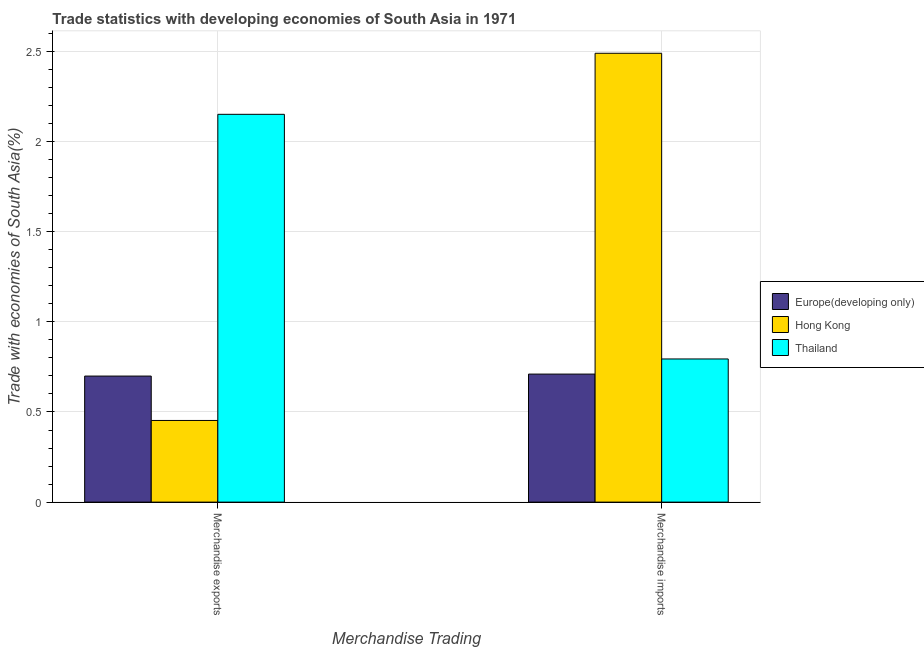How many different coloured bars are there?
Ensure brevity in your answer.  3. Are the number of bars on each tick of the X-axis equal?
Offer a very short reply. Yes. What is the merchandise exports in Thailand?
Give a very brief answer. 2.15. Across all countries, what is the maximum merchandise imports?
Your response must be concise. 2.49. Across all countries, what is the minimum merchandise imports?
Offer a terse response. 0.71. In which country was the merchandise imports maximum?
Ensure brevity in your answer.  Hong Kong. In which country was the merchandise exports minimum?
Ensure brevity in your answer.  Hong Kong. What is the total merchandise exports in the graph?
Keep it short and to the point. 3.3. What is the difference between the merchandise exports in Hong Kong and that in Europe(developing only)?
Provide a short and direct response. -0.25. What is the difference between the merchandise exports in Europe(developing only) and the merchandise imports in Hong Kong?
Provide a short and direct response. -1.79. What is the average merchandise imports per country?
Your response must be concise. 1.33. What is the difference between the merchandise imports and merchandise exports in Hong Kong?
Keep it short and to the point. 2.04. In how many countries, is the merchandise imports greater than 0.2 %?
Your answer should be very brief. 3. What is the ratio of the merchandise exports in Thailand to that in Europe(developing only)?
Your answer should be compact. 3.08. In how many countries, is the merchandise imports greater than the average merchandise imports taken over all countries?
Ensure brevity in your answer.  1. What does the 3rd bar from the left in Merchandise exports represents?
Your answer should be very brief. Thailand. What does the 3rd bar from the right in Merchandise exports represents?
Ensure brevity in your answer.  Europe(developing only). How many bars are there?
Your answer should be very brief. 6. Are all the bars in the graph horizontal?
Keep it short and to the point. No. What is the difference between two consecutive major ticks on the Y-axis?
Your response must be concise. 0.5. Does the graph contain grids?
Offer a very short reply. Yes. Where does the legend appear in the graph?
Keep it short and to the point. Center right. How are the legend labels stacked?
Your answer should be compact. Vertical. What is the title of the graph?
Give a very brief answer. Trade statistics with developing economies of South Asia in 1971. What is the label or title of the X-axis?
Your response must be concise. Merchandise Trading. What is the label or title of the Y-axis?
Offer a terse response. Trade with economies of South Asia(%). What is the Trade with economies of South Asia(%) in Europe(developing only) in Merchandise exports?
Offer a terse response. 0.7. What is the Trade with economies of South Asia(%) of Hong Kong in Merchandise exports?
Your response must be concise. 0.45. What is the Trade with economies of South Asia(%) of Thailand in Merchandise exports?
Keep it short and to the point. 2.15. What is the Trade with economies of South Asia(%) of Europe(developing only) in Merchandise imports?
Provide a short and direct response. 0.71. What is the Trade with economies of South Asia(%) in Hong Kong in Merchandise imports?
Your response must be concise. 2.49. What is the Trade with economies of South Asia(%) in Thailand in Merchandise imports?
Offer a very short reply. 0.79. Across all Merchandise Trading, what is the maximum Trade with economies of South Asia(%) in Europe(developing only)?
Make the answer very short. 0.71. Across all Merchandise Trading, what is the maximum Trade with economies of South Asia(%) of Hong Kong?
Give a very brief answer. 2.49. Across all Merchandise Trading, what is the maximum Trade with economies of South Asia(%) of Thailand?
Give a very brief answer. 2.15. Across all Merchandise Trading, what is the minimum Trade with economies of South Asia(%) of Europe(developing only)?
Your response must be concise. 0.7. Across all Merchandise Trading, what is the minimum Trade with economies of South Asia(%) in Hong Kong?
Keep it short and to the point. 0.45. Across all Merchandise Trading, what is the minimum Trade with economies of South Asia(%) in Thailand?
Offer a terse response. 0.79. What is the total Trade with economies of South Asia(%) of Europe(developing only) in the graph?
Your answer should be very brief. 1.41. What is the total Trade with economies of South Asia(%) in Hong Kong in the graph?
Provide a succinct answer. 2.94. What is the total Trade with economies of South Asia(%) of Thailand in the graph?
Offer a terse response. 2.95. What is the difference between the Trade with economies of South Asia(%) in Europe(developing only) in Merchandise exports and that in Merchandise imports?
Your answer should be compact. -0.01. What is the difference between the Trade with economies of South Asia(%) in Hong Kong in Merchandise exports and that in Merchandise imports?
Give a very brief answer. -2.04. What is the difference between the Trade with economies of South Asia(%) of Thailand in Merchandise exports and that in Merchandise imports?
Provide a short and direct response. 1.36. What is the difference between the Trade with economies of South Asia(%) in Europe(developing only) in Merchandise exports and the Trade with economies of South Asia(%) in Hong Kong in Merchandise imports?
Your answer should be compact. -1.79. What is the difference between the Trade with economies of South Asia(%) of Europe(developing only) in Merchandise exports and the Trade with economies of South Asia(%) of Thailand in Merchandise imports?
Your response must be concise. -0.09. What is the difference between the Trade with economies of South Asia(%) in Hong Kong in Merchandise exports and the Trade with economies of South Asia(%) in Thailand in Merchandise imports?
Offer a very short reply. -0.34. What is the average Trade with economies of South Asia(%) of Europe(developing only) per Merchandise Trading?
Ensure brevity in your answer.  0.7. What is the average Trade with economies of South Asia(%) of Hong Kong per Merchandise Trading?
Your answer should be very brief. 1.47. What is the average Trade with economies of South Asia(%) of Thailand per Merchandise Trading?
Ensure brevity in your answer.  1.47. What is the difference between the Trade with economies of South Asia(%) in Europe(developing only) and Trade with economies of South Asia(%) in Hong Kong in Merchandise exports?
Make the answer very short. 0.25. What is the difference between the Trade with economies of South Asia(%) of Europe(developing only) and Trade with economies of South Asia(%) of Thailand in Merchandise exports?
Offer a terse response. -1.45. What is the difference between the Trade with economies of South Asia(%) of Hong Kong and Trade with economies of South Asia(%) of Thailand in Merchandise exports?
Provide a short and direct response. -1.7. What is the difference between the Trade with economies of South Asia(%) in Europe(developing only) and Trade with economies of South Asia(%) in Hong Kong in Merchandise imports?
Provide a succinct answer. -1.78. What is the difference between the Trade with economies of South Asia(%) in Europe(developing only) and Trade with economies of South Asia(%) in Thailand in Merchandise imports?
Offer a very short reply. -0.08. What is the difference between the Trade with economies of South Asia(%) of Hong Kong and Trade with economies of South Asia(%) of Thailand in Merchandise imports?
Offer a very short reply. 1.7. What is the ratio of the Trade with economies of South Asia(%) in Europe(developing only) in Merchandise exports to that in Merchandise imports?
Provide a short and direct response. 0.98. What is the ratio of the Trade with economies of South Asia(%) of Hong Kong in Merchandise exports to that in Merchandise imports?
Offer a very short reply. 0.18. What is the ratio of the Trade with economies of South Asia(%) in Thailand in Merchandise exports to that in Merchandise imports?
Ensure brevity in your answer.  2.71. What is the difference between the highest and the second highest Trade with economies of South Asia(%) in Europe(developing only)?
Ensure brevity in your answer.  0.01. What is the difference between the highest and the second highest Trade with economies of South Asia(%) of Hong Kong?
Ensure brevity in your answer.  2.04. What is the difference between the highest and the second highest Trade with economies of South Asia(%) of Thailand?
Make the answer very short. 1.36. What is the difference between the highest and the lowest Trade with economies of South Asia(%) in Europe(developing only)?
Offer a very short reply. 0.01. What is the difference between the highest and the lowest Trade with economies of South Asia(%) of Hong Kong?
Your response must be concise. 2.04. What is the difference between the highest and the lowest Trade with economies of South Asia(%) of Thailand?
Ensure brevity in your answer.  1.36. 